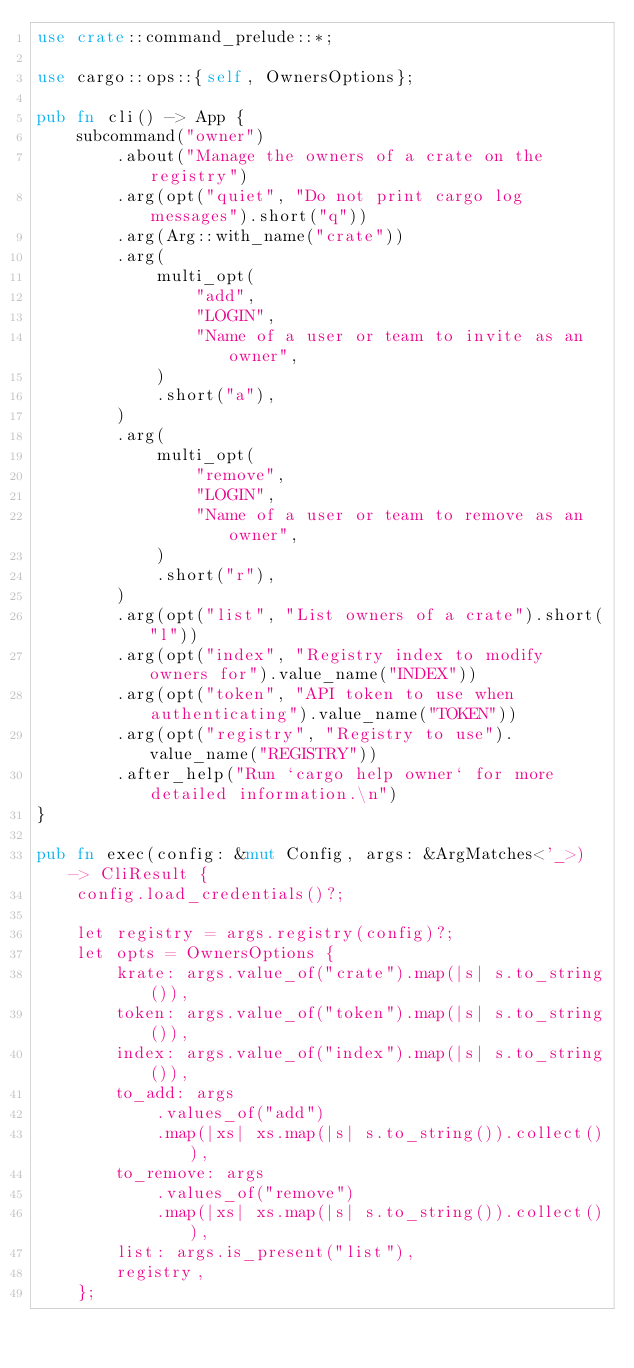<code> <loc_0><loc_0><loc_500><loc_500><_Rust_>use crate::command_prelude::*;

use cargo::ops::{self, OwnersOptions};

pub fn cli() -> App {
    subcommand("owner")
        .about("Manage the owners of a crate on the registry")
        .arg(opt("quiet", "Do not print cargo log messages").short("q"))
        .arg(Arg::with_name("crate"))
        .arg(
            multi_opt(
                "add",
                "LOGIN",
                "Name of a user or team to invite as an owner",
            )
            .short("a"),
        )
        .arg(
            multi_opt(
                "remove",
                "LOGIN",
                "Name of a user or team to remove as an owner",
            )
            .short("r"),
        )
        .arg(opt("list", "List owners of a crate").short("l"))
        .arg(opt("index", "Registry index to modify owners for").value_name("INDEX"))
        .arg(opt("token", "API token to use when authenticating").value_name("TOKEN"))
        .arg(opt("registry", "Registry to use").value_name("REGISTRY"))
        .after_help("Run `cargo help owner` for more detailed information.\n")
}

pub fn exec(config: &mut Config, args: &ArgMatches<'_>) -> CliResult {
    config.load_credentials()?;

    let registry = args.registry(config)?;
    let opts = OwnersOptions {
        krate: args.value_of("crate").map(|s| s.to_string()),
        token: args.value_of("token").map(|s| s.to_string()),
        index: args.value_of("index").map(|s| s.to_string()),
        to_add: args
            .values_of("add")
            .map(|xs| xs.map(|s| s.to_string()).collect()),
        to_remove: args
            .values_of("remove")
            .map(|xs| xs.map(|s| s.to_string()).collect()),
        list: args.is_present("list"),
        registry,
    };</code> 